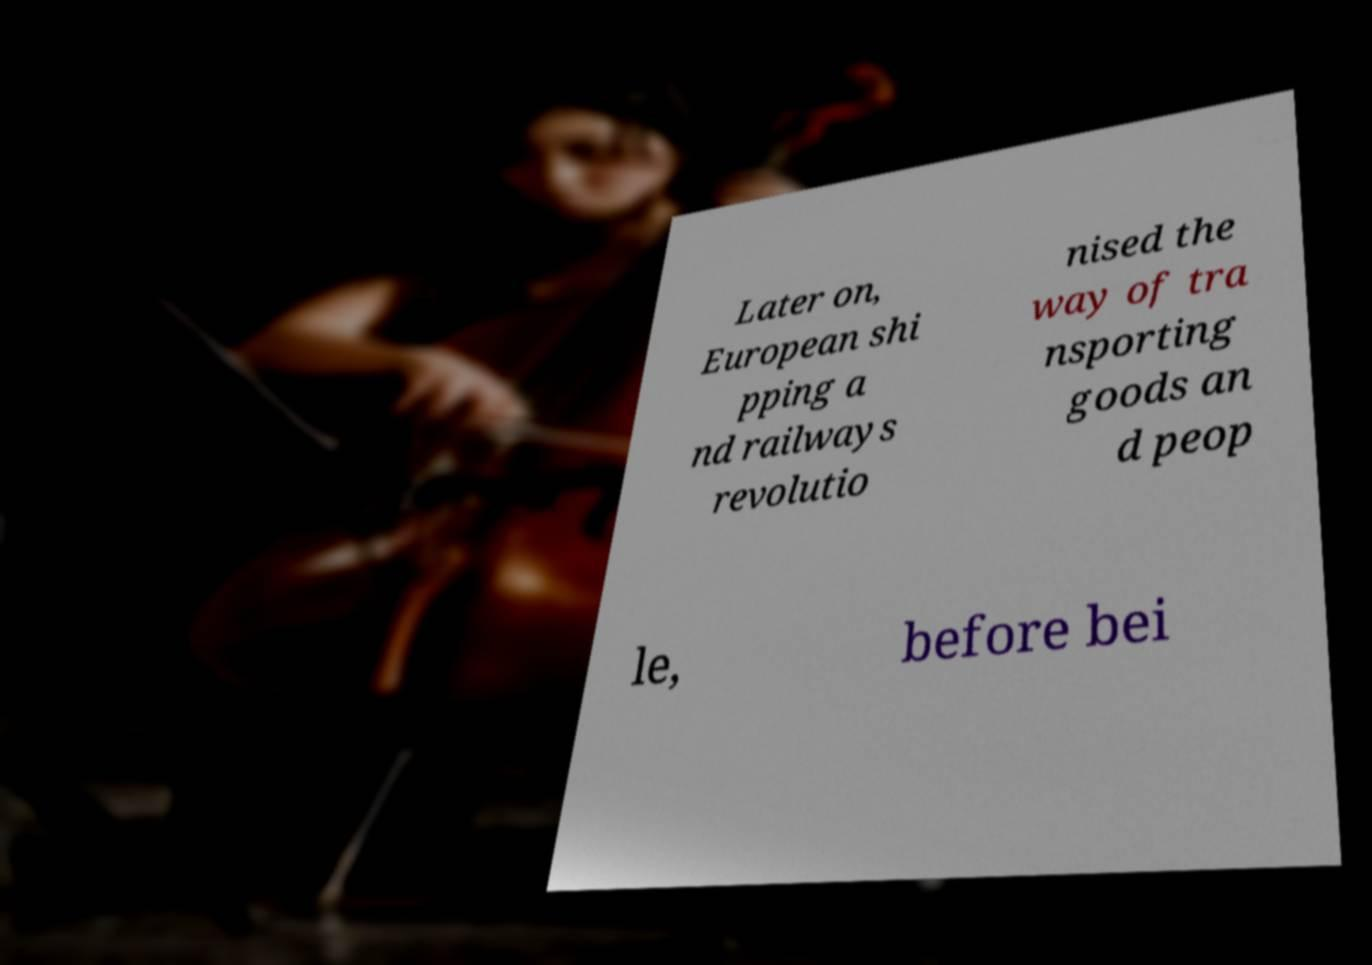There's text embedded in this image that I need extracted. Can you transcribe it verbatim? Later on, European shi pping a nd railways revolutio nised the way of tra nsporting goods an d peop le, before bei 